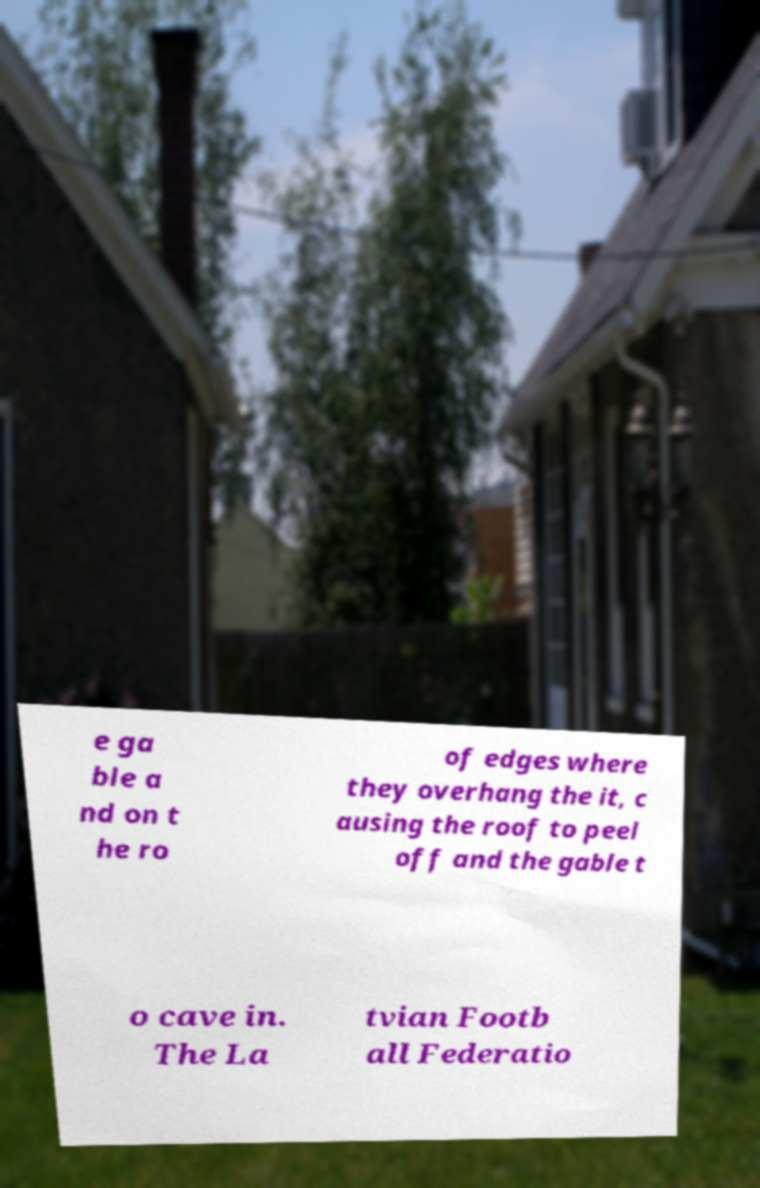What messages or text are displayed in this image? I need them in a readable, typed format. e ga ble a nd on t he ro of edges where they overhang the it, c ausing the roof to peel off and the gable t o cave in. The La tvian Footb all Federatio 